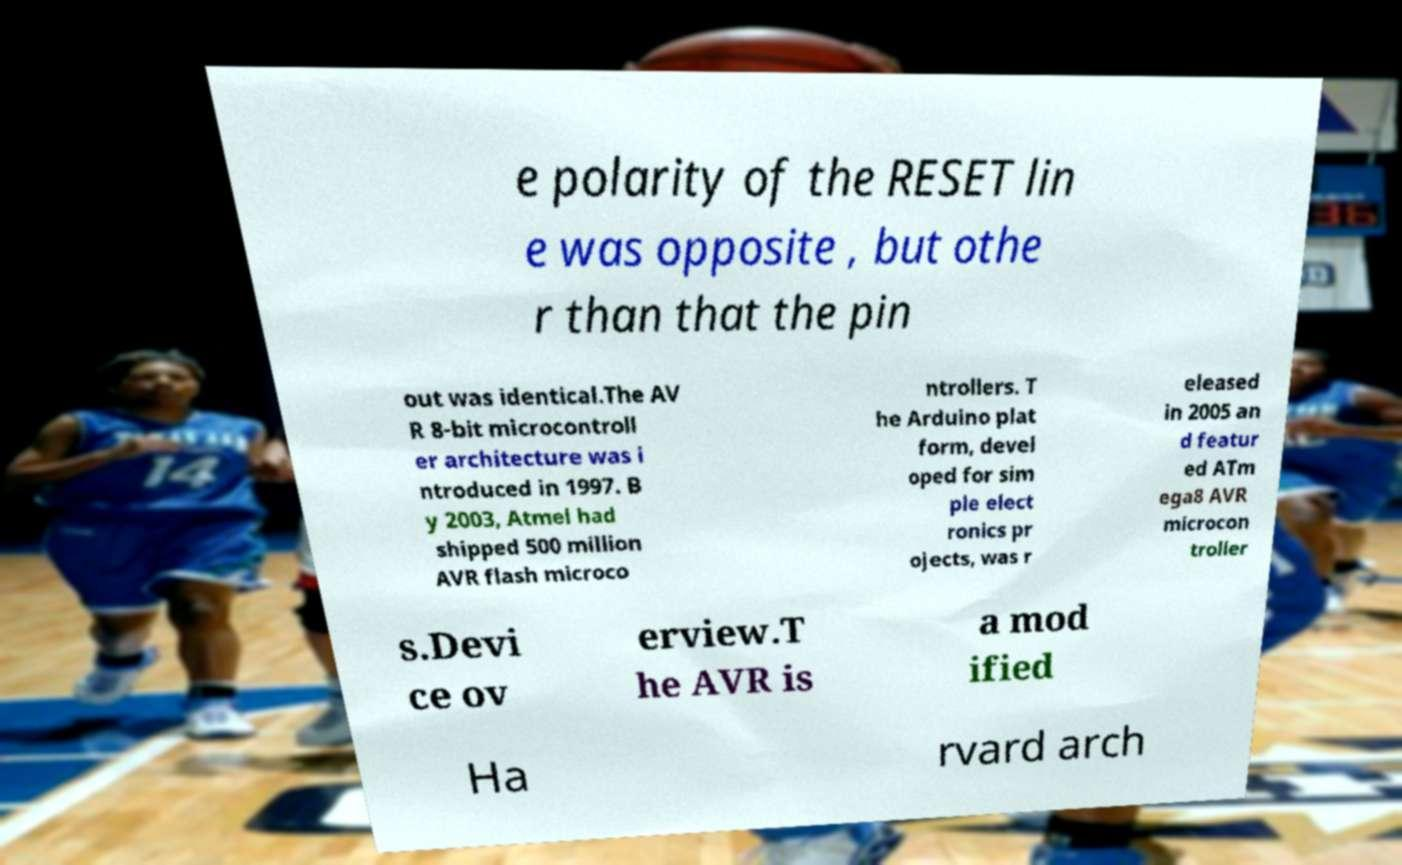Please read and relay the text visible in this image. What does it say? e polarity of the RESET lin e was opposite , but othe r than that the pin out was identical.The AV R 8-bit microcontroll er architecture was i ntroduced in 1997. B y 2003, Atmel had shipped 500 million AVR flash microco ntrollers. T he Arduino plat form, devel oped for sim ple elect ronics pr ojects, was r eleased in 2005 an d featur ed ATm ega8 AVR microcon troller s.Devi ce ov erview.T he AVR is a mod ified Ha rvard arch 